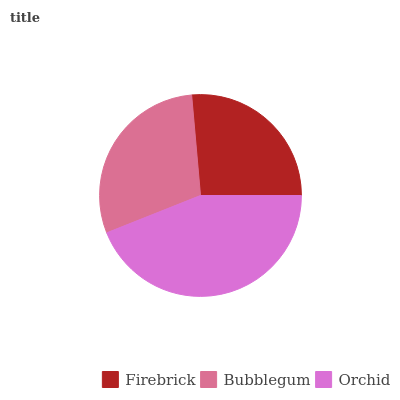Is Firebrick the minimum?
Answer yes or no. Yes. Is Orchid the maximum?
Answer yes or no. Yes. Is Bubblegum the minimum?
Answer yes or no. No. Is Bubblegum the maximum?
Answer yes or no. No. Is Bubblegum greater than Firebrick?
Answer yes or no. Yes. Is Firebrick less than Bubblegum?
Answer yes or no. Yes. Is Firebrick greater than Bubblegum?
Answer yes or no. No. Is Bubblegum less than Firebrick?
Answer yes or no. No. Is Bubblegum the high median?
Answer yes or no. Yes. Is Bubblegum the low median?
Answer yes or no. Yes. Is Firebrick the high median?
Answer yes or no. No. Is Orchid the low median?
Answer yes or no. No. 